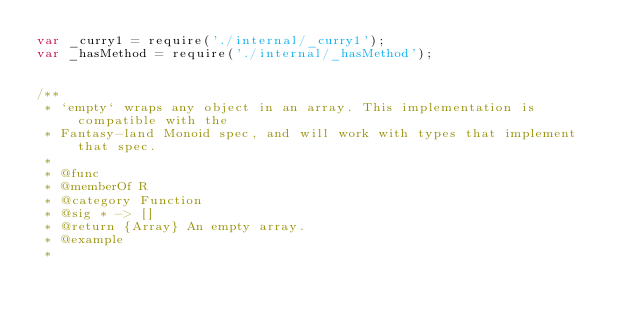Convert code to text. <code><loc_0><loc_0><loc_500><loc_500><_JavaScript_>var _curry1 = require('./internal/_curry1');
var _hasMethod = require('./internal/_hasMethod');


/**
 * `empty` wraps any object in an array. This implementation is compatible with the
 * Fantasy-land Monoid spec, and will work with types that implement that spec.
 *
 * @func
 * @memberOf R
 * @category Function
 * @sig * -> []
 * @return {Array} An empty array.
 * @example
 *</code> 